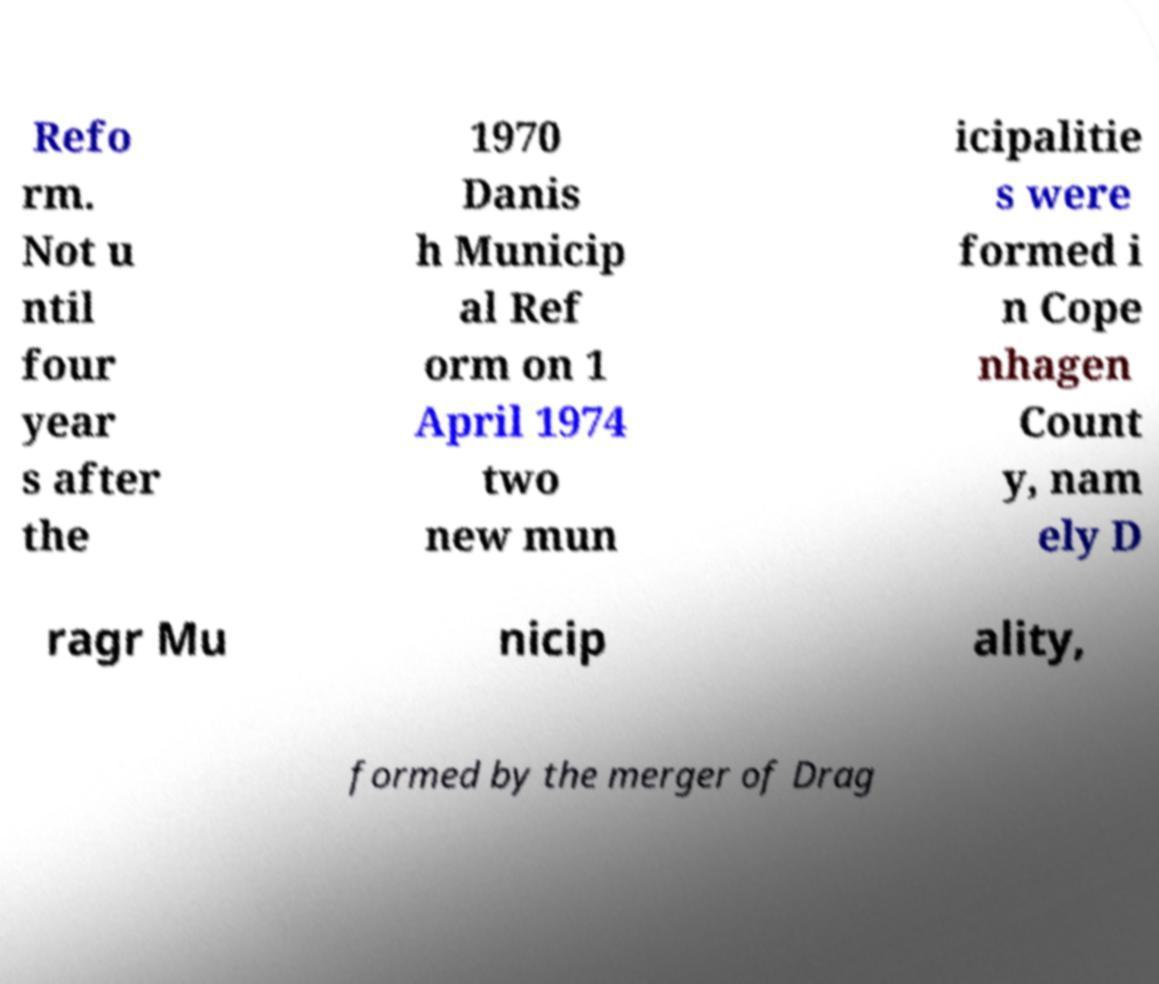Could you assist in decoding the text presented in this image and type it out clearly? Refo rm. Not u ntil four year s after the 1970 Danis h Municip al Ref orm on 1 April 1974 two new mun icipalitie s were formed i n Cope nhagen Count y, nam ely D ragr Mu nicip ality, formed by the merger of Drag 